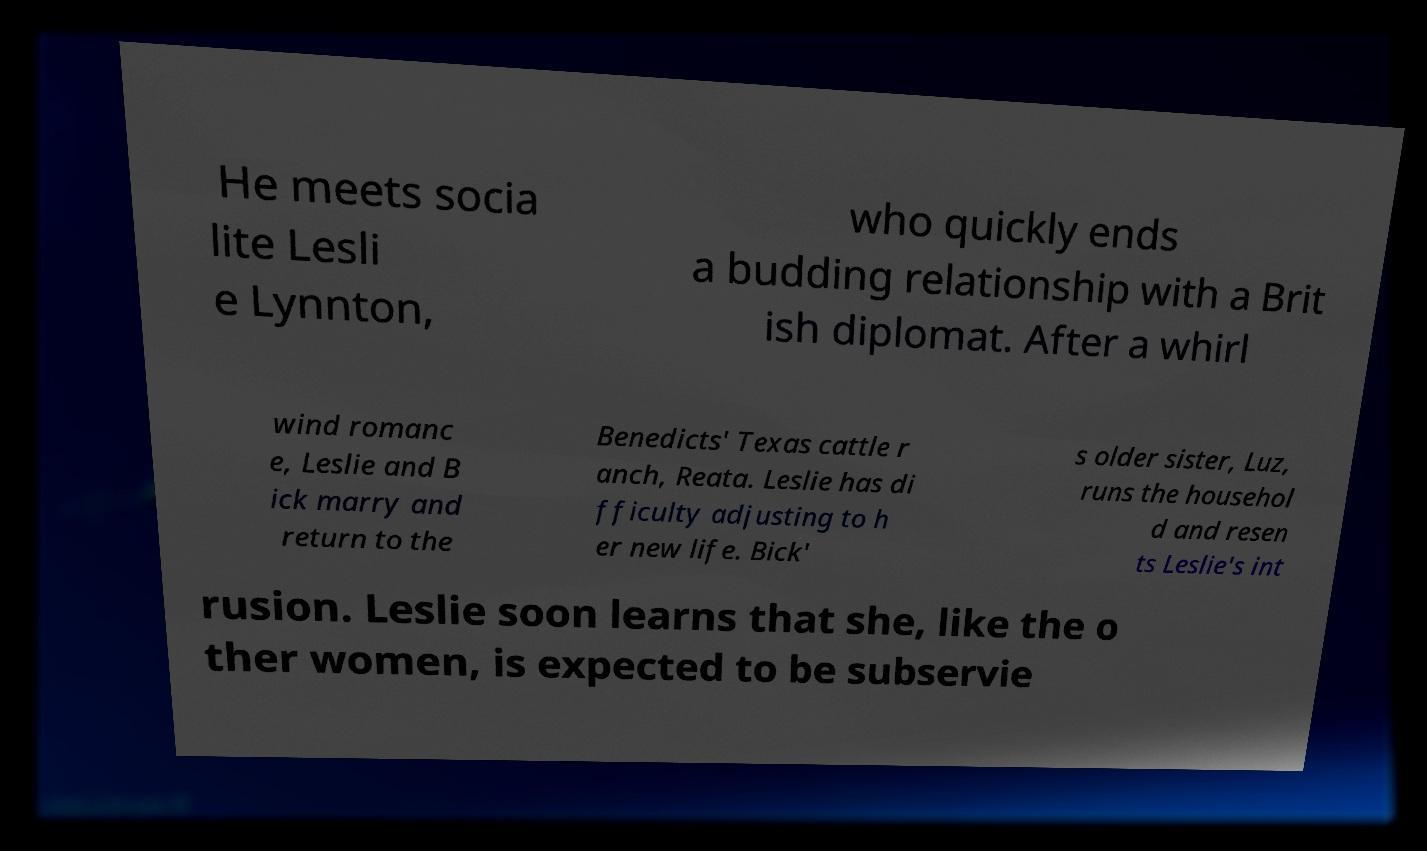Could you extract and type out the text from this image? He meets socia lite Lesli e Lynnton, who quickly ends a budding relationship with a Brit ish diplomat. After a whirl wind romanc e, Leslie and B ick marry and return to the Benedicts' Texas cattle r anch, Reata. Leslie has di fficulty adjusting to h er new life. Bick' s older sister, Luz, runs the househol d and resen ts Leslie's int rusion. Leslie soon learns that she, like the o ther women, is expected to be subservie 